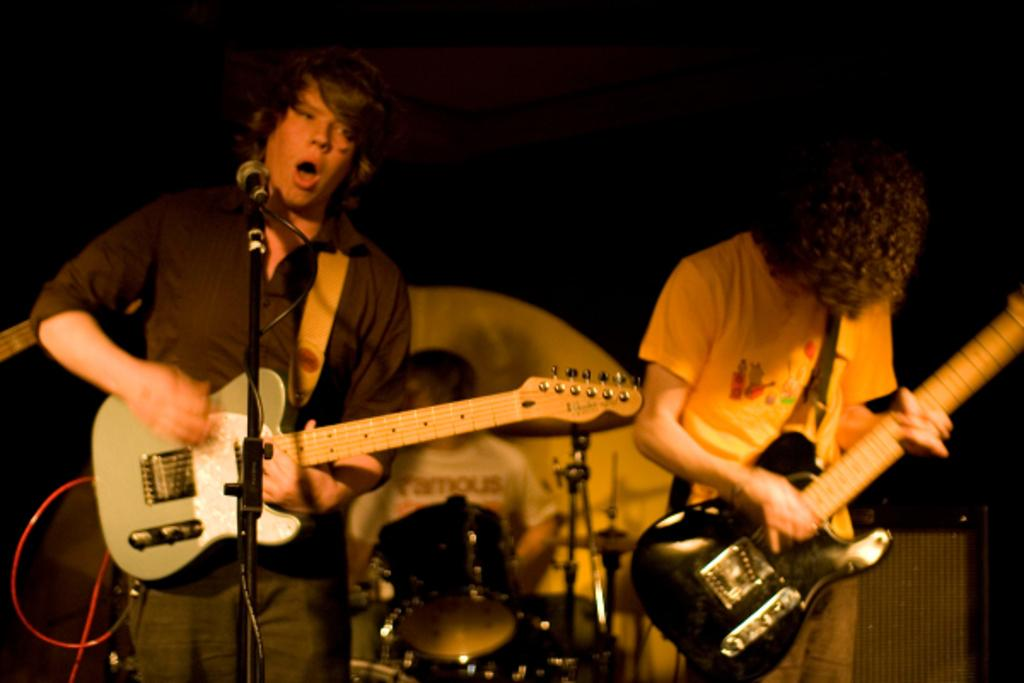How many people are in the image? There are two persons in the image. What are the two persons doing? The two persons are playing guitar. What object is present for amplifying their voices? There is a microphone (mike) in the image. What type of objects are visible that are related to music? There are musical instruments in the image. How much money is being exchanged between the two persons in the image? There is no indication of money being exchanged in the image; the focus is on the two persons playing guitar and using a microphone. 